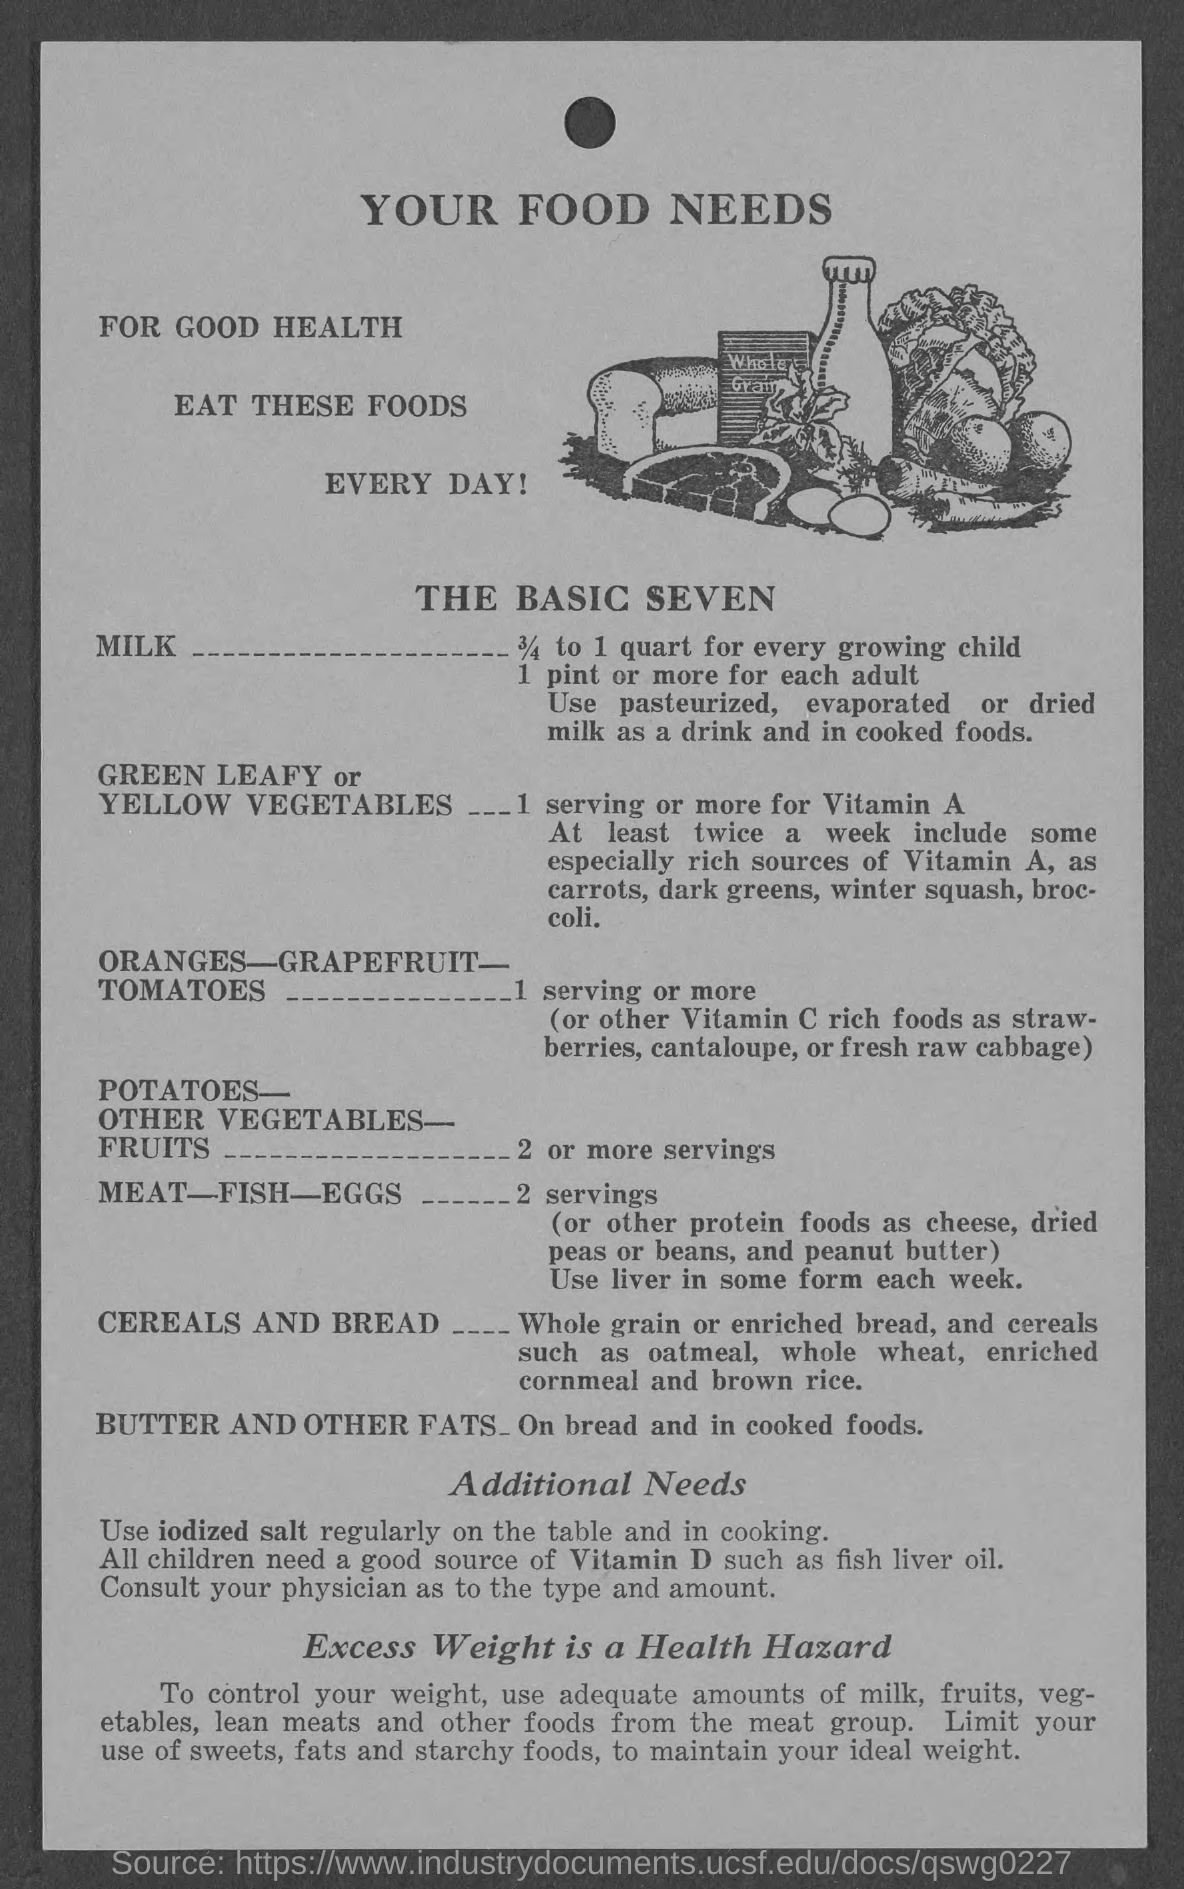What is the Title of the document?
Ensure brevity in your answer.  Your food needs. How much milk for every growing child?
Your answer should be compact. 3/4 to 1 quart. 